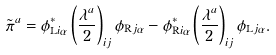Convert formula to latex. <formula><loc_0><loc_0><loc_500><loc_500>\tilde { \pi } ^ { a } = \phi _ { \text {L} i \alpha } ^ { \ast } \left ( \frac { \lambda ^ { a } } { 2 } \right ) _ { i j } \phi _ { \text {R} j \alpha } - \phi _ { \text {R} i \alpha } ^ { \ast } \left ( \frac { \lambda ^ { a } } { 2 } \right ) _ { i j } \phi _ { \text {L} j \alpha } .</formula> 